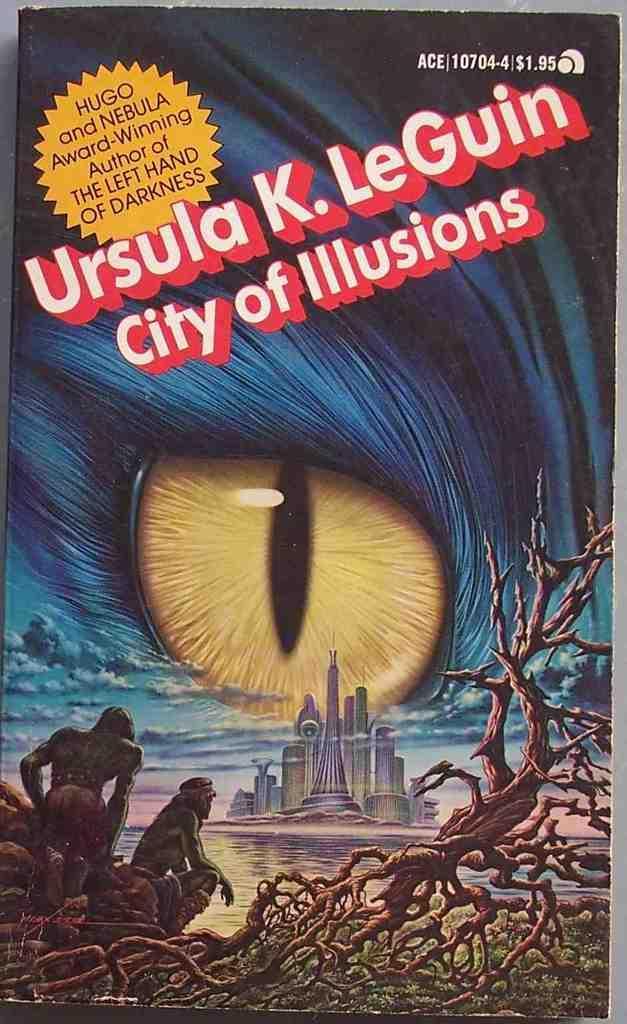Describe this image in one or two sentences. In this image we can see the poster on which we can see an eye, people, building, trunk and some text written on it. 